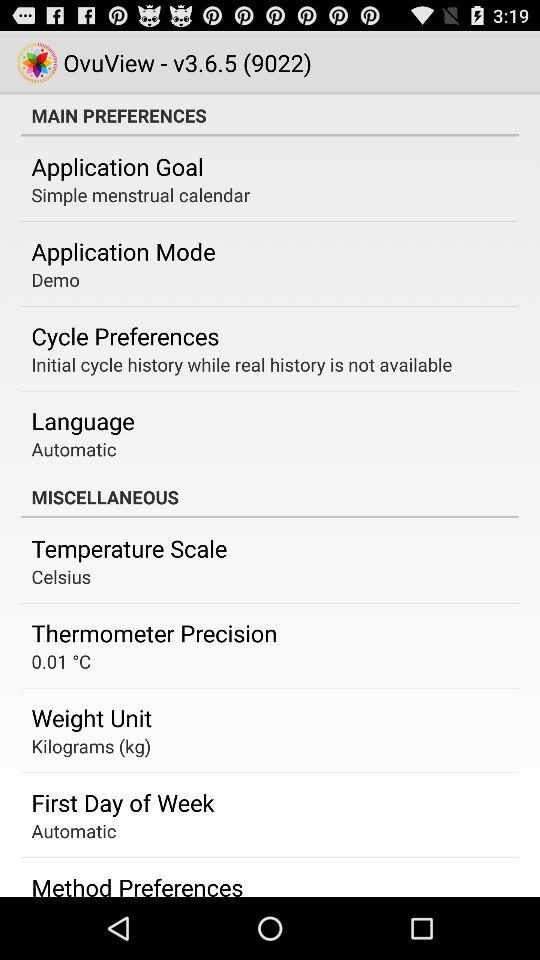What is the temperature scale? The temperature scale is "Celsius". 